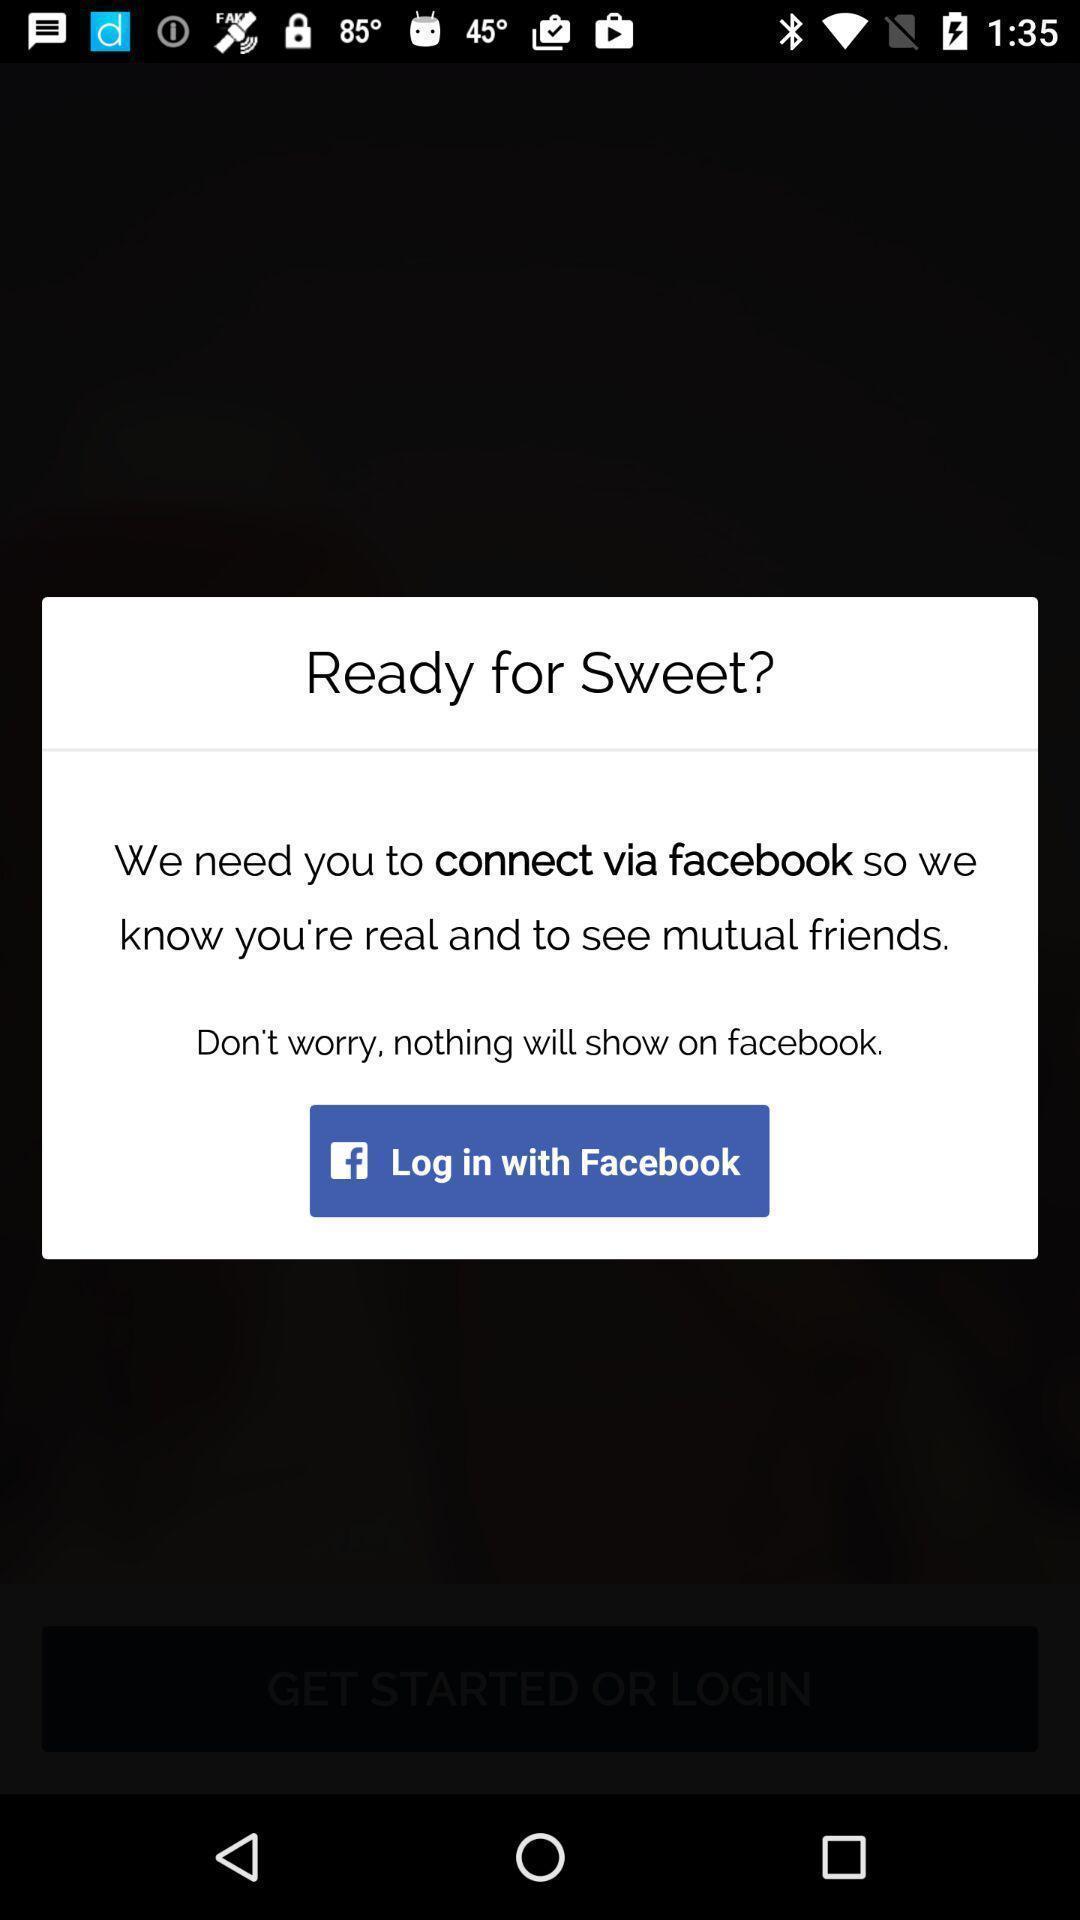Summarize the information in this screenshot. Pop-up showing login with social app. 